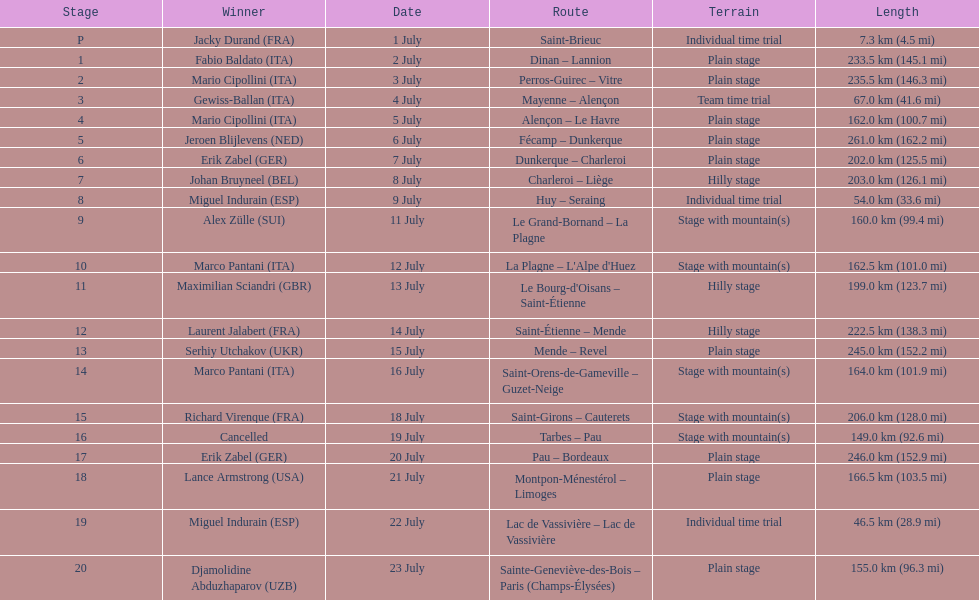How many consecutive km were raced on july 8th? 203.0 km (126.1 mi). 